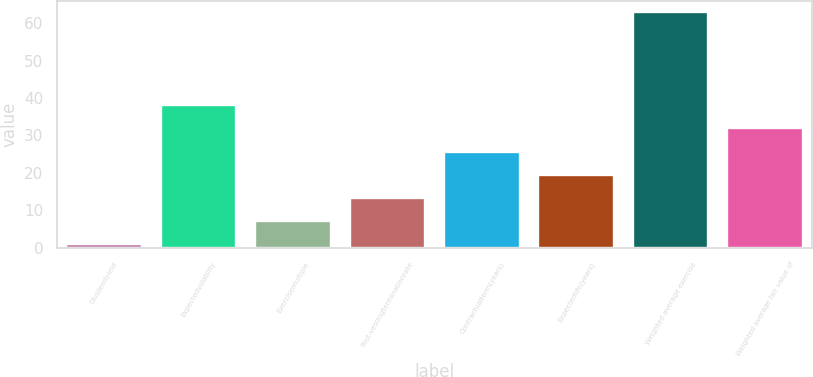Convert chart to OTSL. <chart><loc_0><loc_0><loc_500><loc_500><bar_chart><fcel>Dividendyield<fcel>Expectedvolatility<fcel>Exercisemultiple<fcel>Post-vestingterminationrate<fcel>Contractualterm(years)<fcel>Expectedlife(years)<fcel>Weighted average exercise<fcel>Weighted average fair value of<nl><fcel>0.94<fcel>38.08<fcel>7.13<fcel>13.32<fcel>25.7<fcel>19.51<fcel>62.86<fcel>31.89<nl></chart> 